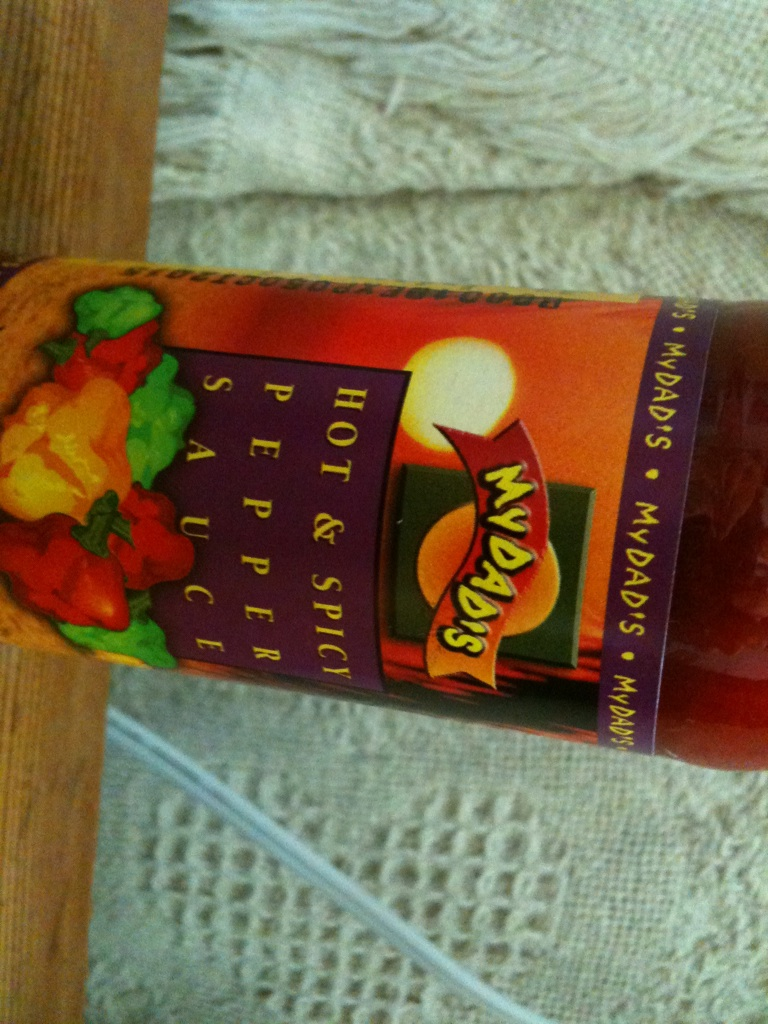What kind of ingredients are likely in this pepper sauce? This pepper sauce likely contains a blend of hot peppers, vinegar, salt, and possibly some spices for added flavor. Some sauces also include garlic, onion, sugar, or citrus to balance the heat with tangy and sweet notes.  Can you provide an extremely detailed description of how this pepper sauce could transform a simple dish? Absolutely! Imagine you have a simple roasted chicken. While delicious, it lacks that special spark. Now, take this bottle of 'MYDAD'S Hot & Spicy Pepper Sauce'. Prepare a marinade utilizing the sauce, combining it with olive oil, fresh lime juice, minced garlic, and finely chopped cilantro. Before roasting, rub the marinade thoroughly over the chicken, making sure to get it underneath the skin as well. As the chicken roasts, the pepper sauce's unique blend of spices and heat permeates the meat, infusing it with a bold, robust flavor. The hot peppers provide a pleasantly fiery kick, balanced perfectly by the tanginess of the lime and the aromatic herbs. The vinegar in the sauce helps to tenderize the chicken, resulting in juicy, flavorful meat. Serve this transformed dish with a side of roasted vegetables, drizzled with a bit more of the pepper sauce for an extra burst of flavor. The once simple chicken dish is now a delightful, gourmet meal bursting with complexity and heat, thanks to the transformative power of the pepper sauce. 